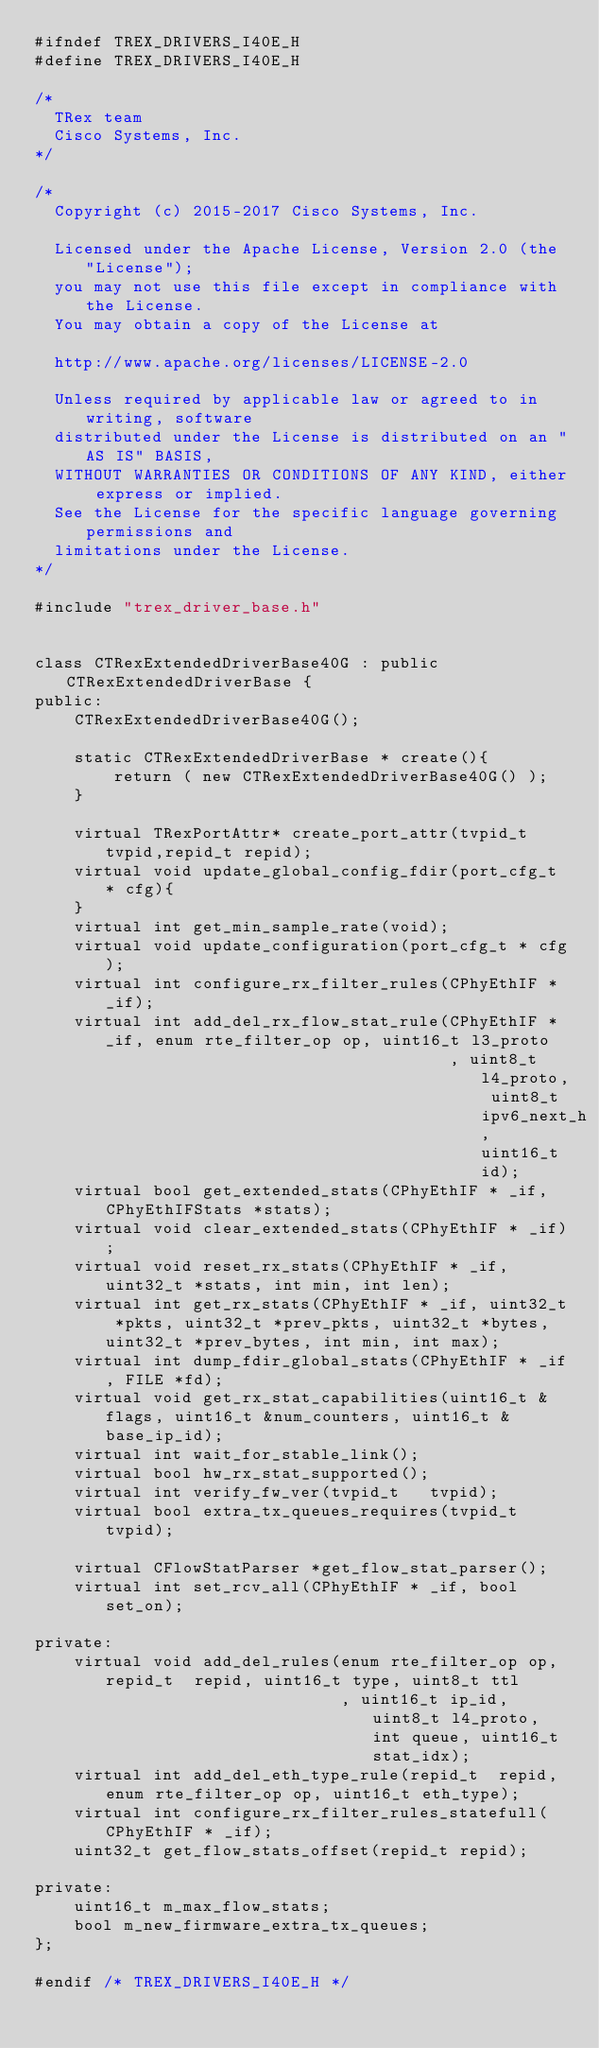Convert code to text. <code><loc_0><loc_0><loc_500><loc_500><_C_>#ifndef TREX_DRIVERS_I40E_H
#define TREX_DRIVERS_I40E_H

/*
  TRex team
  Cisco Systems, Inc.
*/

/*
  Copyright (c) 2015-2017 Cisco Systems, Inc.

  Licensed under the Apache License, Version 2.0 (the "License");
  you may not use this file except in compliance with the License.
  You may obtain a copy of the License at

  http://www.apache.org/licenses/LICENSE-2.0

  Unless required by applicable law or agreed to in writing, software
  distributed under the License is distributed on an "AS IS" BASIS,
  WITHOUT WARRANTIES OR CONDITIONS OF ANY KIND, either express or implied.
  See the License for the specific language governing permissions and
  limitations under the License.
*/

#include "trex_driver_base.h"


class CTRexExtendedDriverBase40G : public CTRexExtendedDriverBase {
public:
    CTRexExtendedDriverBase40G();

    static CTRexExtendedDriverBase * create(){
        return ( new CTRexExtendedDriverBase40G() );
    }

    virtual TRexPortAttr* create_port_attr(tvpid_t tvpid,repid_t repid);
    virtual void update_global_config_fdir(port_cfg_t * cfg){
    }
    virtual int get_min_sample_rate(void);
    virtual void update_configuration(port_cfg_t * cfg);
    virtual int configure_rx_filter_rules(CPhyEthIF * _if);
    virtual int add_del_rx_flow_stat_rule(CPhyEthIF * _if, enum rte_filter_op op, uint16_t l3_proto
                                          , uint8_t l4_proto, uint8_t ipv6_next_h, uint16_t id);
    virtual bool get_extended_stats(CPhyEthIF * _if,CPhyEthIFStats *stats);
    virtual void clear_extended_stats(CPhyEthIF * _if);
    virtual void reset_rx_stats(CPhyEthIF * _if, uint32_t *stats, int min, int len);
    virtual int get_rx_stats(CPhyEthIF * _if, uint32_t *pkts, uint32_t *prev_pkts, uint32_t *bytes, uint32_t *prev_bytes, int min, int max);
    virtual int dump_fdir_global_stats(CPhyEthIF * _if, FILE *fd);
    virtual void get_rx_stat_capabilities(uint16_t &flags, uint16_t &num_counters, uint16_t &base_ip_id);
    virtual int wait_for_stable_link();
    virtual bool hw_rx_stat_supported();
    virtual int verify_fw_ver(tvpid_t   tvpid);
    virtual bool extra_tx_queues_requires(tvpid_t tvpid);

    virtual CFlowStatParser *get_flow_stat_parser();
    virtual int set_rcv_all(CPhyEthIF * _if, bool set_on);

private:
    virtual void add_del_rules(enum rte_filter_op op, repid_t  repid, uint16_t type, uint8_t ttl
                               , uint16_t ip_id, uint8_t l4_proto, int queue, uint16_t stat_idx);
    virtual int add_del_eth_type_rule(repid_t  repid, enum rte_filter_op op, uint16_t eth_type);
    virtual int configure_rx_filter_rules_statefull(CPhyEthIF * _if);
    uint32_t get_flow_stats_offset(repid_t repid);

private:
    uint16_t m_max_flow_stats;
    bool m_new_firmware_extra_tx_queues; 
};

#endif /* TREX_DRIVERS_I40E_H */
</code> 